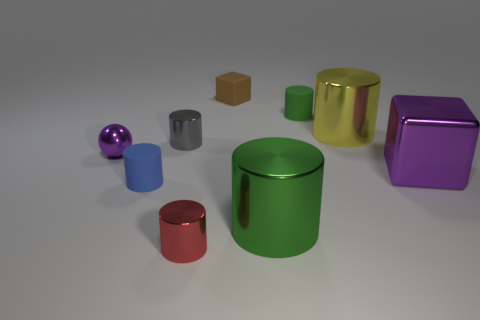How many objects are either big red matte cylinders or large things that are on the left side of the big yellow metal object?
Keep it short and to the point. 1. How many other objects are there of the same size as the brown rubber object?
Ensure brevity in your answer.  5. Is the cylinder behind the yellow metal thing made of the same material as the block that is to the right of the brown object?
Ensure brevity in your answer.  No. How many big green objects are behind the brown matte object?
Your answer should be compact. 0. How many green things are either metal balls or large metallic objects?
Offer a very short reply. 1. There is a green object that is the same size as the purple cube; what is it made of?
Provide a short and direct response. Metal. What is the shape of the tiny object that is in front of the big shiny cube and behind the red shiny cylinder?
Offer a terse response. Cylinder. There is another cylinder that is the same size as the yellow cylinder; what color is it?
Make the answer very short. Green. There is a purple thing that is on the right side of the tiny gray metallic thing; is its size the same as the purple metal object that is on the left side of the large yellow metal cylinder?
Your answer should be very brief. No. There is a purple metallic object that is to the right of the tiny matte cylinder that is left of the big cylinder that is to the left of the yellow shiny object; what is its size?
Offer a very short reply. Large. 